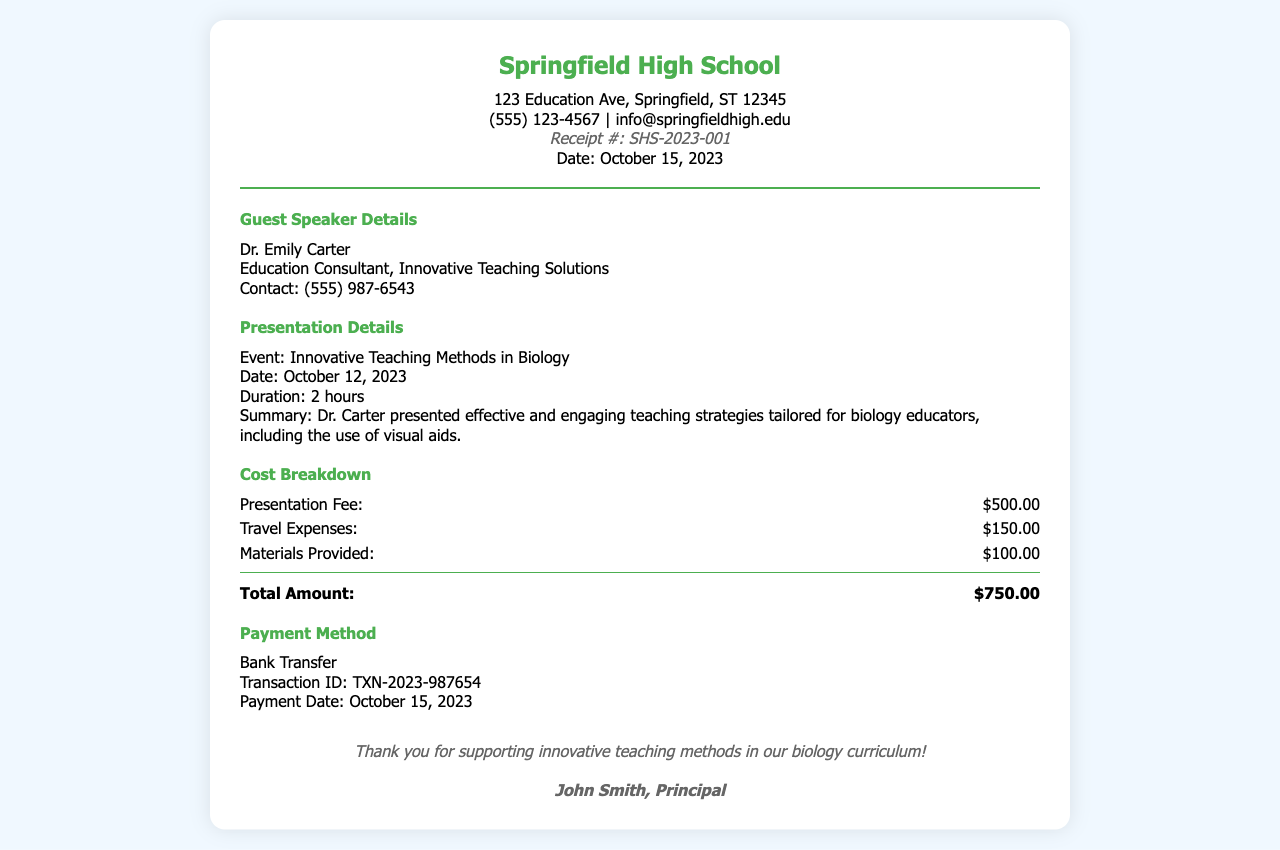What is the event title? The event title is specified in the Presentation Details section.
Answer: Innovative Teaching Methods in Biology Who is the guest speaker? The name of the guest speaker is listed in the Guest Speaker Details section.
Answer: Dr. Emily Carter What was the presentation fee? The presentation fee is included in the Cost Breakdown section.
Answer: $500.00 What is the total amount? The total amount is calculated by adding all costs listed in the Cost Breakdown section.
Answer: $750.00 When was the presentation held? The date of the presentation is noted in the Presentation Details section.
Answer: October 12, 2023 What payment method was used? The payment method is outlined in the Payment Method section.
Answer: Bank Transfer What was the duration of the presentation? The duration of the presentation is mentioned under the Presentation Details section.
Answer: 2 hours What is the transaction ID? The transaction ID can be found in the Payment Method section.
Answer: TXN-2023-987654 Who signed the receipt? The signature is found at the bottom of the receipt.
Answer: John Smith, Principal 